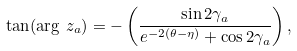Convert formula to latex. <formula><loc_0><loc_0><loc_500><loc_500>\tan ( \arg \, z _ { a } ) = - \left ( \frac { \sin 2 \gamma _ { a } } { e ^ { - 2 ( \theta - \eta ) } + \cos 2 \gamma _ { a } } \right ) ,</formula> 